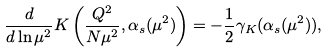Convert formula to latex. <formula><loc_0><loc_0><loc_500><loc_500>\frac { d } { d \ln \mu ^ { 2 } } K \left ( \frac { Q ^ { 2 } } { N \mu ^ { 2 } } , \alpha _ { s } ( \mu ^ { 2 } ) \right ) = - \frac { 1 } { 2 } \gamma _ { K } ( \alpha _ { s } ( \mu ^ { 2 } ) ) ,</formula> 